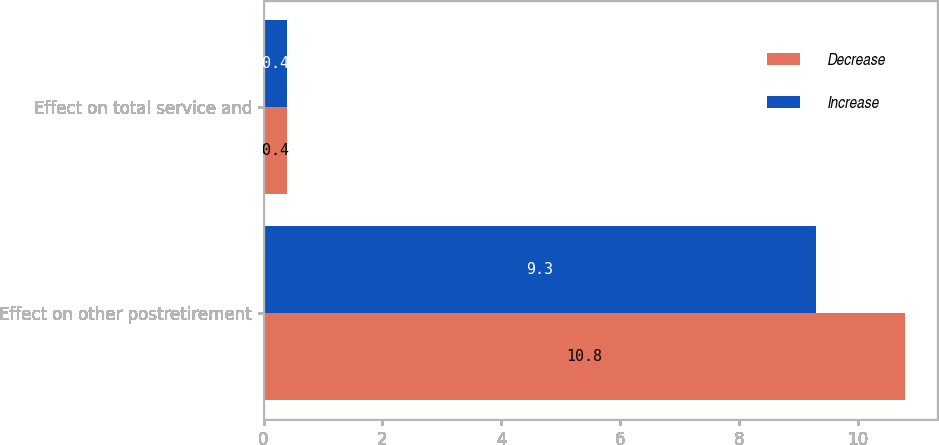<chart> <loc_0><loc_0><loc_500><loc_500><stacked_bar_chart><ecel><fcel>Effect on other postretirement<fcel>Effect on total service and<nl><fcel>Decrease<fcel>10.8<fcel>0.4<nl><fcel>Increase<fcel>9.3<fcel>0.4<nl></chart> 